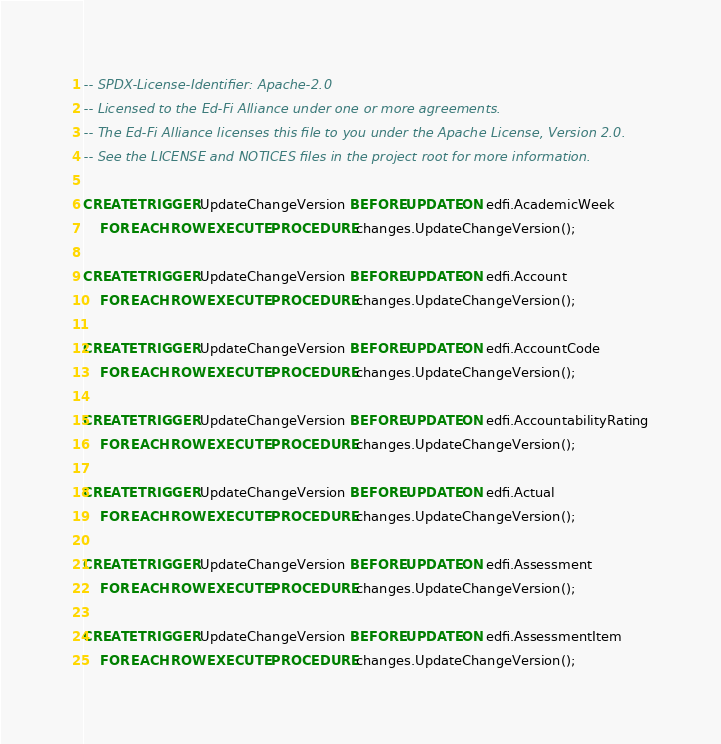Convert code to text. <code><loc_0><loc_0><loc_500><loc_500><_SQL_>-- SPDX-License-Identifier: Apache-2.0
-- Licensed to the Ed-Fi Alliance under one or more agreements.
-- The Ed-Fi Alliance licenses this file to you under the Apache License, Version 2.0.
-- See the LICENSE and NOTICES files in the project root for more information.

CREATE TRIGGER UpdateChangeVersion BEFORE UPDATE ON edfi.AcademicWeek
    FOR EACH ROW EXECUTE PROCEDURE changes.UpdateChangeVersion();

CREATE TRIGGER UpdateChangeVersion BEFORE UPDATE ON edfi.Account
    FOR EACH ROW EXECUTE PROCEDURE changes.UpdateChangeVersion();

CREATE TRIGGER UpdateChangeVersion BEFORE UPDATE ON edfi.AccountCode
    FOR EACH ROW EXECUTE PROCEDURE changes.UpdateChangeVersion();

CREATE TRIGGER UpdateChangeVersion BEFORE UPDATE ON edfi.AccountabilityRating
    FOR EACH ROW EXECUTE PROCEDURE changes.UpdateChangeVersion();

CREATE TRIGGER UpdateChangeVersion BEFORE UPDATE ON edfi.Actual
    FOR EACH ROW EXECUTE PROCEDURE changes.UpdateChangeVersion();

CREATE TRIGGER UpdateChangeVersion BEFORE UPDATE ON edfi.Assessment
    FOR EACH ROW EXECUTE PROCEDURE changes.UpdateChangeVersion();

CREATE TRIGGER UpdateChangeVersion BEFORE UPDATE ON edfi.AssessmentItem
    FOR EACH ROW EXECUTE PROCEDURE changes.UpdateChangeVersion();
</code> 